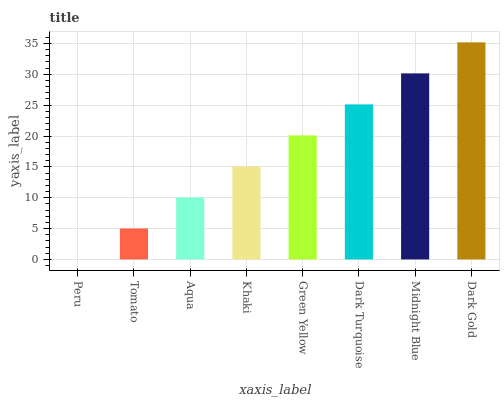Is Peru the minimum?
Answer yes or no. Yes. Is Dark Gold the maximum?
Answer yes or no. Yes. Is Tomato the minimum?
Answer yes or no. No. Is Tomato the maximum?
Answer yes or no. No. Is Tomato greater than Peru?
Answer yes or no. Yes. Is Peru less than Tomato?
Answer yes or no. Yes. Is Peru greater than Tomato?
Answer yes or no. No. Is Tomato less than Peru?
Answer yes or no. No. Is Green Yellow the high median?
Answer yes or no. Yes. Is Khaki the low median?
Answer yes or no. Yes. Is Peru the high median?
Answer yes or no. No. Is Peru the low median?
Answer yes or no. No. 